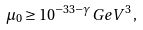<formula> <loc_0><loc_0><loc_500><loc_500>\mu _ { 0 } \geq 1 0 ^ { - 3 3 - \gamma } G e V ^ { 3 } \, ,</formula> 